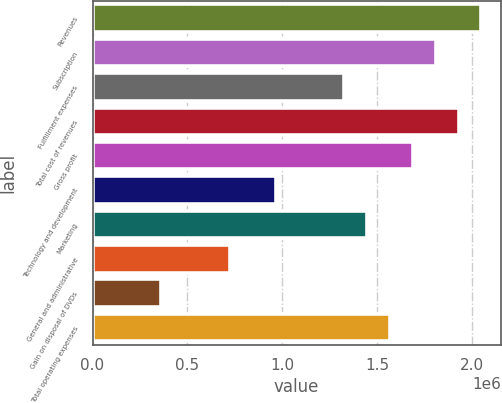<chart> <loc_0><loc_0><loc_500><loc_500><bar_chart><fcel>Revenues<fcel>Subscription<fcel>Fulfillment expenses<fcel>Total cost of revenues<fcel>Gross profit<fcel>Technology and development<fcel>Marketing<fcel>General and administrative<fcel>Gain on disposal of DVDs<fcel>Total operating expenses<nl><fcel>2.04908e+06<fcel>1.80801e+06<fcel>1.32587e+06<fcel>1.92854e+06<fcel>1.68748e+06<fcel>964272<fcel>1.44641e+06<fcel>723204<fcel>361603<fcel>1.56694e+06<nl></chart> 